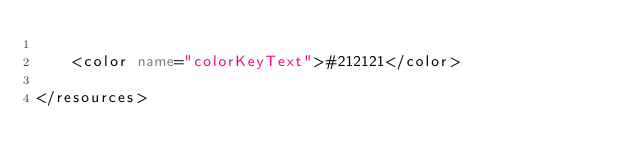<code> <loc_0><loc_0><loc_500><loc_500><_XML_>
    <color name="colorKeyText">#212121</color>
    
</resources>
</code> 